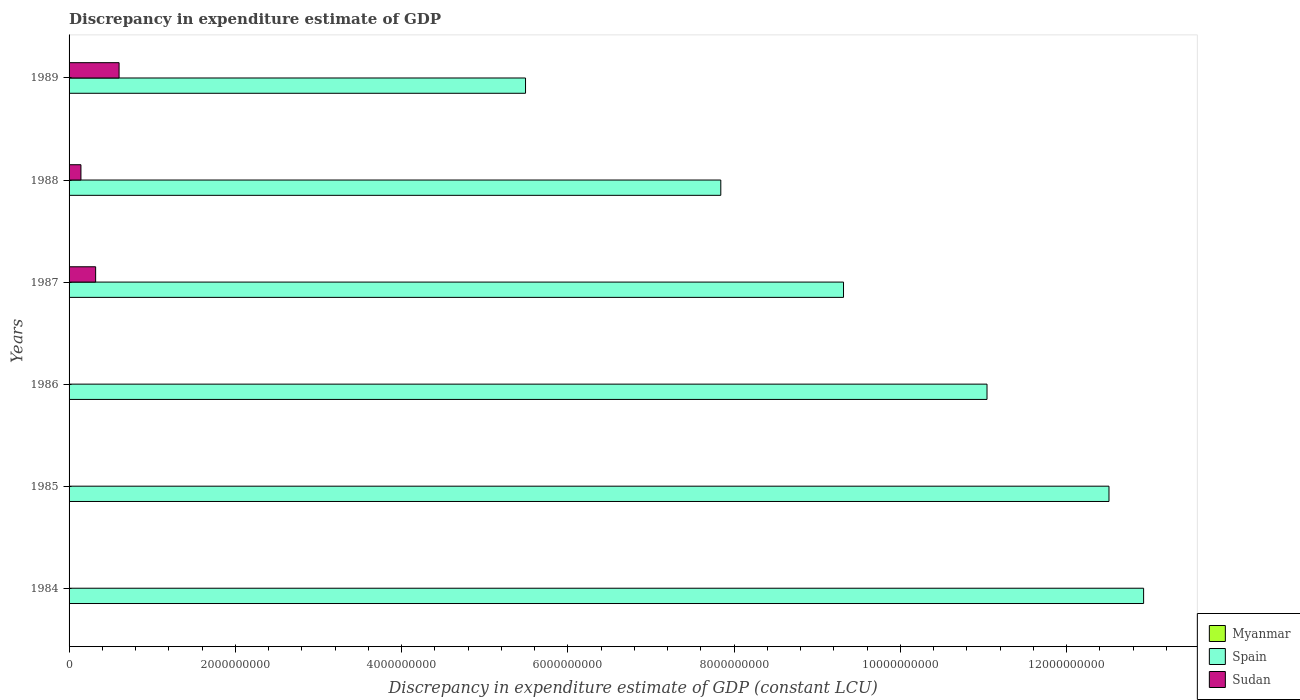Are the number of bars per tick equal to the number of legend labels?
Provide a short and direct response. No. How many bars are there on the 5th tick from the top?
Offer a very short reply. 1. What is the label of the 3rd group of bars from the top?
Your answer should be very brief. 1987. In how many cases, is the number of bars for a given year not equal to the number of legend labels?
Offer a terse response. 6. Across all years, what is the maximum discrepancy in expenditure estimate of GDP in Sudan?
Make the answer very short. 6.02e+08. What is the total discrepancy in expenditure estimate of GDP in Myanmar in the graph?
Make the answer very short. 0. What is the difference between the discrepancy in expenditure estimate of GDP in Sudan in 1987 and that in 1989?
Offer a terse response. -2.82e+08. What is the difference between the discrepancy in expenditure estimate of GDP in Myanmar in 1987 and the discrepancy in expenditure estimate of GDP in Sudan in 1989?
Offer a terse response. -6.02e+08. In the year 1987, what is the difference between the discrepancy in expenditure estimate of GDP in Sudan and discrepancy in expenditure estimate of GDP in Spain?
Your response must be concise. -9.00e+09. In how many years, is the discrepancy in expenditure estimate of GDP in Myanmar greater than 3200000000 LCU?
Ensure brevity in your answer.  0. What is the ratio of the discrepancy in expenditure estimate of GDP in Spain in 1986 to that in 1989?
Offer a very short reply. 2.01. Is the difference between the discrepancy in expenditure estimate of GDP in Sudan in 1987 and 1988 greater than the difference between the discrepancy in expenditure estimate of GDP in Spain in 1987 and 1988?
Provide a short and direct response. No. What is the difference between the highest and the second highest discrepancy in expenditure estimate of GDP in Spain?
Offer a very short reply. 4.17e+08. What is the difference between the highest and the lowest discrepancy in expenditure estimate of GDP in Spain?
Ensure brevity in your answer.  7.44e+09. How many bars are there?
Your answer should be compact. 9. What is the difference between two consecutive major ticks on the X-axis?
Give a very brief answer. 2.00e+09. Are the values on the major ticks of X-axis written in scientific E-notation?
Provide a succinct answer. No. Does the graph contain any zero values?
Provide a succinct answer. Yes. How many legend labels are there?
Keep it short and to the point. 3. What is the title of the graph?
Offer a terse response. Discrepancy in expenditure estimate of GDP. What is the label or title of the X-axis?
Your response must be concise. Discrepancy in expenditure estimate of GDP (constant LCU). What is the label or title of the Y-axis?
Keep it short and to the point. Years. What is the Discrepancy in expenditure estimate of GDP (constant LCU) in Spain in 1984?
Your answer should be very brief. 1.29e+1. What is the Discrepancy in expenditure estimate of GDP (constant LCU) of Sudan in 1984?
Offer a very short reply. 0. What is the Discrepancy in expenditure estimate of GDP (constant LCU) of Myanmar in 1985?
Make the answer very short. 0. What is the Discrepancy in expenditure estimate of GDP (constant LCU) in Spain in 1985?
Make the answer very short. 1.25e+1. What is the Discrepancy in expenditure estimate of GDP (constant LCU) of Myanmar in 1986?
Offer a very short reply. 0. What is the Discrepancy in expenditure estimate of GDP (constant LCU) of Spain in 1986?
Provide a succinct answer. 1.10e+1. What is the Discrepancy in expenditure estimate of GDP (constant LCU) of Spain in 1987?
Provide a short and direct response. 9.32e+09. What is the Discrepancy in expenditure estimate of GDP (constant LCU) in Sudan in 1987?
Your response must be concise. 3.20e+08. What is the Discrepancy in expenditure estimate of GDP (constant LCU) of Myanmar in 1988?
Keep it short and to the point. 0. What is the Discrepancy in expenditure estimate of GDP (constant LCU) in Spain in 1988?
Make the answer very short. 7.84e+09. What is the Discrepancy in expenditure estimate of GDP (constant LCU) in Sudan in 1988?
Your answer should be compact. 1.43e+08. What is the Discrepancy in expenditure estimate of GDP (constant LCU) of Spain in 1989?
Ensure brevity in your answer.  5.49e+09. What is the Discrepancy in expenditure estimate of GDP (constant LCU) of Sudan in 1989?
Your answer should be compact. 6.02e+08. Across all years, what is the maximum Discrepancy in expenditure estimate of GDP (constant LCU) of Spain?
Your response must be concise. 1.29e+1. Across all years, what is the maximum Discrepancy in expenditure estimate of GDP (constant LCU) in Sudan?
Your answer should be compact. 6.02e+08. Across all years, what is the minimum Discrepancy in expenditure estimate of GDP (constant LCU) in Spain?
Provide a succinct answer. 5.49e+09. Across all years, what is the minimum Discrepancy in expenditure estimate of GDP (constant LCU) in Sudan?
Your answer should be very brief. 0. What is the total Discrepancy in expenditure estimate of GDP (constant LCU) of Spain in the graph?
Make the answer very short. 5.91e+1. What is the total Discrepancy in expenditure estimate of GDP (constant LCU) of Sudan in the graph?
Ensure brevity in your answer.  1.06e+09. What is the difference between the Discrepancy in expenditure estimate of GDP (constant LCU) of Spain in 1984 and that in 1985?
Give a very brief answer. 4.17e+08. What is the difference between the Discrepancy in expenditure estimate of GDP (constant LCU) of Spain in 1984 and that in 1986?
Ensure brevity in your answer.  1.88e+09. What is the difference between the Discrepancy in expenditure estimate of GDP (constant LCU) in Spain in 1984 and that in 1987?
Offer a terse response. 3.61e+09. What is the difference between the Discrepancy in expenditure estimate of GDP (constant LCU) in Spain in 1984 and that in 1988?
Your response must be concise. 5.09e+09. What is the difference between the Discrepancy in expenditure estimate of GDP (constant LCU) of Spain in 1984 and that in 1989?
Give a very brief answer. 7.44e+09. What is the difference between the Discrepancy in expenditure estimate of GDP (constant LCU) of Spain in 1985 and that in 1986?
Your answer should be compact. 1.47e+09. What is the difference between the Discrepancy in expenditure estimate of GDP (constant LCU) of Spain in 1985 and that in 1987?
Give a very brief answer. 3.19e+09. What is the difference between the Discrepancy in expenditure estimate of GDP (constant LCU) in Spain in 1985 and that in 1988?
Make the answer very short. 4.67e+09. What is the difference between the Discrepancy in expenditure estimate of GDP (constant LCU) of Spain in 1985 and that in 1989?
Your response must be concise. 7.02e+09. What is the difference between the Discrepancy in expenditure estimate of GDP (constant LCU) in Spain in 1986 and that in 1987?
Ensure brevity in your answer.  1.73e+09. What is the difference between the Discrepancy in expenditure estimate of GDP (constant LCU) of Spain in 1986 and that in 1988?
Make the answer very short. 3.20e+09. What is the difference between the Discrepancy in expenditure estimate of GDP (constant LCU) in Spain in 1986 and that in 1989?
Offer a very short reply. 5.55e+09. What is the difference between the Discrepancy in expenditure estimate of GDP (constant LCU) of Spain in 1987 and that in 1988?
Provide a short and direct response. 1.48e+09. What is the difference between the Discrepancy in expenditure estimate of GDP (constant LCU) in Sudan in 1987 and that in 1988?
Keep it short and to the point. 1.77e+08. What is the difference between the Discrepancy in expenditure estimate of GDP (constant LCU) in Spain in 1987 and that in 1989?
Keep it short and to the point. 3.83e+09. What is the difference between the Discrepancy in expenditure estimate of GDP (constant LCU) of Sudan in 1987 and that in 1989?
Provide a short and direct response. -2.82e+08. What is the difference between the Discrepancy in expenditure estimate of GDP (constant LCU) of Spain in 1988 and that in 1989?
Make the answer very short. 2.35e+09. What is the difference between the Discrepancy in expenditure estimate of GDP (constant LCU) in Sudan in 1988 and that in 1989?
Make the answer very short. -4.59e+08. What is the difference between the Discrepancy in expenditure estimate of GDP (constant LCU) of Spain in 1984 and the Discrepancy in expenditure estimate of GDP (constant LCU) of Sudan in 1987?
Make the answer very short. 1.26e+1. What is the difference between the Discrepancy in expenditure estimate of GDP (constant LCU) in Spain in 1984 and the Discrepancy in expenditure estimate of GDP (constant LCU) in Sudan in 1988?
Give a very brief answer. 1.28e+1. What is the difference between the Discrepancy in expenditure estimate of GDP (constant LCU) of Spain in 1984 and the Discrepancy in expenditure estimate of GDP (constant LCU) of Sudan in 1989?
Your answer should be compact. 1.23e+1. What is the difference between the Discrepancy in expenditure estimate of GDP (constant LCU) in Spain in 1985 and the Discrepancy in expenditure estimate of GDP (constant LCU) in Sudan in 1987?
Provide a succinct answer. 1.22e+1. What is the difference between the Discrepancy in expenditure estimate of GDP (constant LCU) of Spain in 1985 and the Discrepancy in expenditure estimate of GDP (constant LCU) of Sudan in 1988?
Offer a terse response. 1.24e+1. What is the difference between the Discrepancy in expenditure estimate of GDP (constant LCU) in Spain in 1985 and the Discrepancy in expenditure estimate of GDP (constant LCU) in Sudan in 1989?
Your answer should be very brief. 1.19e+1. What is the difference between the Discrepancy in expenditure estimate of GDP (constant LCU) of Spain in 1986 and the Discrepancy in expenditure estimate of GDP (constant LCU) of Sudan in 1987?
Make the answer very short. 1.07e+1. What is the difference between the Discrepancy in expenditure estimate of GDP (constant LCU) of Spain in 1986 and the Discrepancy in expenditure estimate of GDP (constant LCU) of Sudan in 1988?
Offer a very short reply. 1.09e+1. What is the difference between the Discrepancy in expenditure estimate of GDP (constant LCU) in Spain in 1986 and the Discrepancy in expenditure estimate of GDP (constant LCU) in Sudan in 1989?
Ensure brevity in your answer.  1.04e+1. What is the difference between the Discrepancy in expenditure estimate of GDP (constant LCU) of Spain in 1987 and the Discrepancy in expenditure estimate of GDP (constant LCU) of Sudan in 1988?
Your answer should be very brief. 9.17e+09. What is the difference between the Discrepancy in expenditure estimate of GDP (constant LCU) of Spain in 1987 and the Discrepancy in expenditure estimate of GDP (constant LCU) of Sudan in 1989?
Offer a very short reply. 8.71e+09. What is the difference between the Discrepancy in expenditure estimate of GDP (constant LCU) in Spain in 1988 and the Discrepancy in expenditure estimate of GDP (constant LCU) in Sudan in 1989?
Keep it short and to the point. 7.24e+09. What is the average Discrepancy in expenditure estimate of GDP (constant LCU) of Myanmar per year?
Give a very brief answer. 0. What is the average Discrepancy in expenditure estimate of GDP (constant LCU) in Spain per year?
Your answer should be compact. 9.85e+09. What is the average Discrepancy in expenditure estimate of GDP (constant LCU) in Sudan per year?
Offer a very short reply. 1.77e+08. In the year 1987, what is the difference between the Discrepancy in expenditure estimate of GDP (constant LCU) in Spain and Discrepancy in expenditure estimate of GDP (constant LCU) in Sudan?
Your answer should be compact. 9.00e+09. In the year 1988, what is the difference between the Discrepancy in expenditure estimate of GDP (constant LCU) of Spain and Discrepancy in expenditure estimate of GDP (constant LCU) of Sudan?
Your answer should be compact. 7.70e+09. In the year 1989, what is the difference between the Discrepancy in expenditure estimate of GDP (constant LCU) in Spain and Discrepancy in expenditure estimate of GDP (constant LCU) in Sudan?
Your answer should be very brief. 4.89e+09. What is the ratio of the Discrepancy in expenditure estimate of GDP (constant LCU) in Spain in 1984 to that in 1986?
Offer a terse response. 1.17. What is the ratio of the Discrepancy in expenditure estimate of GDP (constant LCU) in Spain in 1984 to that in 1987?
Make the answer very short. 1.39. What is the ratio of the Discrepancy in expenditure estimate of GDP (constant LCU) in Spain in 1984 to that in 1988?
Ensure brevity in your answer.  1.65. What is the ratio of the Discrepancy in expenditure estimate of GDP (constant LCU) of Spain in 1984 to that in 1989?
Offer a very short reply. 2.35. What is the ratio of the Discrepancy in expenditure estimate of GDP (constant LCU) in Spain in 1985 to that in 1986?
Make the answer very short. 1.13. What is the ratio of the Discrepancy in expenditure estimate of GDP (constant LCU) of Spain in 1985 to that in 1987?
Your answer should be compact. 1.34. What is the ratio of the Discrepancy in expenditure estimate of GDP (constant LCU) in Spain in 1985 to that in 1988?
Provide a succinct answer. 1.6. What is the ratio of the Discrepancy in expenditure estimate of GDP (constant LCU) of Spain in 1985 to that in 1989?
Give a very brief answer. 2.28. What is the ratio of the Discrepancy in expenditure estimate of GDP (constant LCU) of Spain in 1986 to that in 1987?
Provide a succinct answer. 1.19. What is the ratio of the Discrepancy in expenditure estimate of GDP (constant LCU) of Spain in 1986 to that in 1988?
Give a very brief answer. 1.41. What is the ratio of the Discrepancy in expenditure estimate of GDP (constant LCU) in Spain in 1986 to that in 1989?
Keep it short and to the point. 2.01. What is the ratio of the Discrepancy in expenditure estimate of GDP (constant LCU) of Spain in 1987 to that in 1988?
Provide a short and direct response. 1.19. What is the ratio of the Discrepancy in expenditure estimate of GDP (constant LCU) of Sudan in 1987 to that in 1988?
Offer a very short reply. 2.24. What is the ratio of the Discrepancy in expenditure estimate of GDP (constant LCU) in Spain in 1987 to that in 1989?
Provide a succinct answer. 1.7. What is the ratio of the Discrepancy in expenditure estimate of GDP (constant LCU) in Sudan in 1987 to that in 1989?
Provide a short and direct response. 0.53. What is the ratio of the Discrepancy in expenditure estimate of GDP (constant LCU) of Spain in 1988 to that in 1989?
Your answer should be very brief. 1.43. What is the ratio of the Discrepancy in expenditure estimate of GDP (constant LCU) in Sudan in 1988 to that in 1989?
Provide a short and direct response. 0.24. What is the difference between the highest and the second highest Discrepancy in expenditure estimate of GDP (constant LCU) of Spain?
Your response must be concise. 4.17e+08. What is the difference between the highest and the second highest Discrepancy in expenditure estimate of GDP (constant LCU) of Sudan?
Your answer should be compact. 2.82e+08. What is the difference between the highest and the lowest Discrepancy in expenditure estimate of GDP (constant LCU) in Spain?
Keep it short and to the point. 7.44e+09. What is the difference between the highest and the lowest Discrepancy in expenditure estimate of GDP (constant LCU) in Sudan?
Offer a terse response. 6.02e+08. 